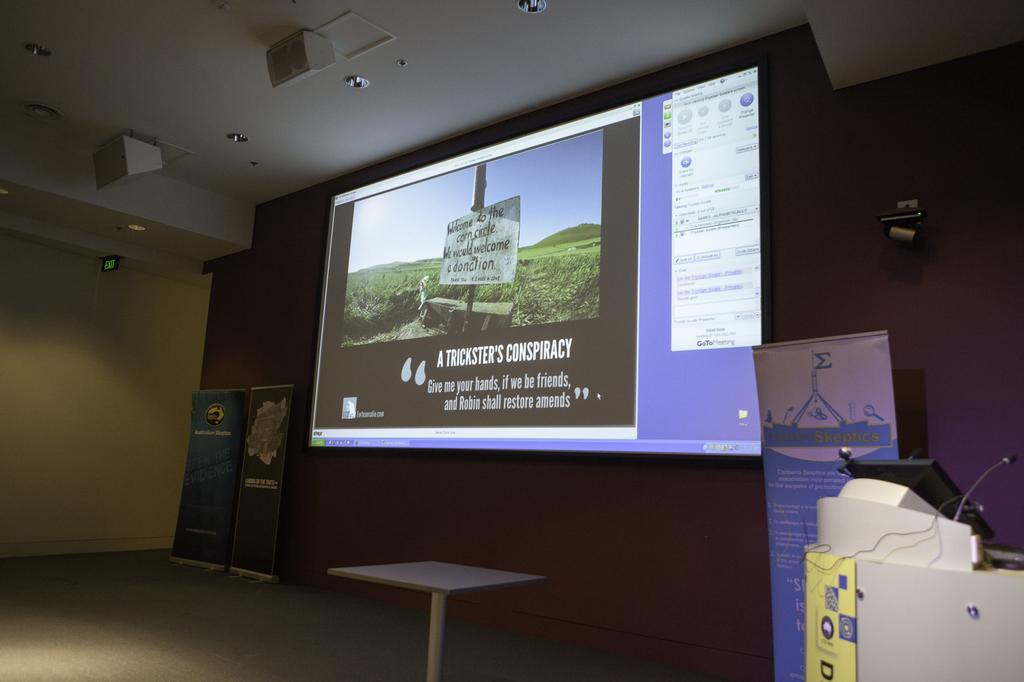What is the main feature of the image? There is a projector screen in the image. What else can be seen in the image besides the projector screen? There are banners, a table, a microphone on the right side, other objects on the right side, a wall, and lights on the ceiling in the image. Where is the microphone located in the image? The microphone is on the right side of the image. What type of objects might be found on a table during an event? The table in the image might have other objects related to the event, such as presentation materials or refreshments. How many sheep are visible on the projector screen in the image? There are no sheep visible on the projector screen in the image. What level of experience does the beginner have with the microphone in the image? There is no indication of the experience level of anyone using the microphone in the image. 